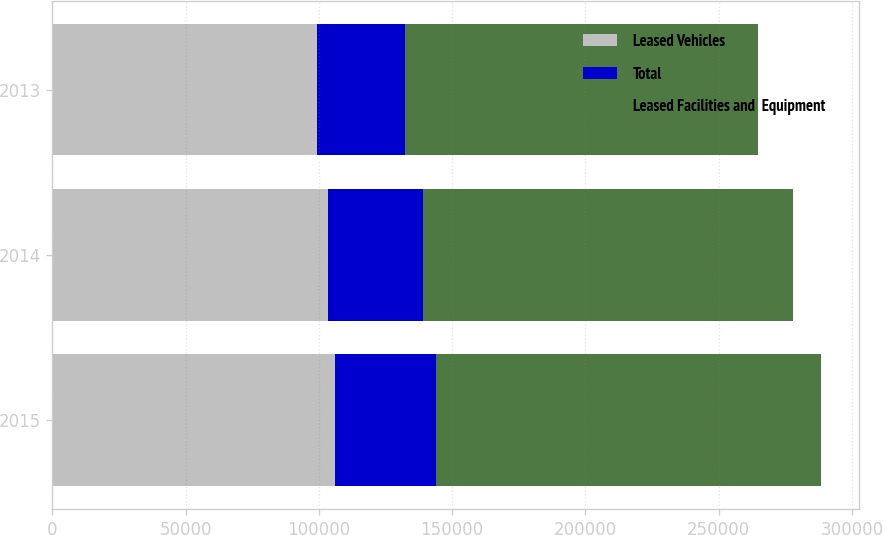Convert chart to OTSL. <chart><loc_0><loc_0><loc_500><loc_500><stacked_bar_chart><ecel><fcel>2015<fcel>2014<fcel>2013<nl><fcel>Leased Vehicles<fcel>105961<fcel>103294<fcel>99483<nl><fcel>Total<fcel>38178<fcel>35731<fcel>32907<nl><fcel>Leased Facilities and  Equipment<fcel>144139<fcel>139025<fcel>132390<nl></chart> 